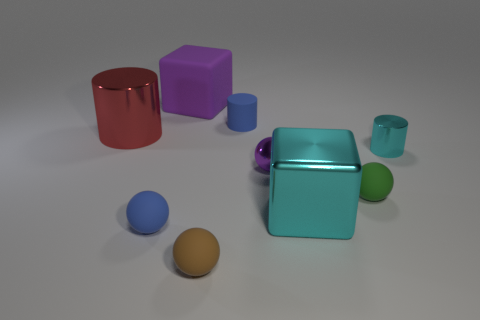Subtract all small blue cylinders. How many cylinders are left? 2 Add 1 tiny blue metal blocks. How many objects exist? 10 Subtract all blue spheres. How many spheres are left? 3 Subtract 2 spheres. How many spheres are left? 2 Subtract all cylinders. How many objects are left? 6 Subtract 0 purple cylinders. How many objects are left? 9 Subtract all gray spheres. Subtract all purple cylinders. How many spheres are left? 4 Subtract all tiny purple spheres. Subtract all small green metal spheres. How many objects are left? 8 Add 6 small balls. How many small balls are left? 10 Add 6 tiny rubber objects. How many tiny rubber objects exist? 10 